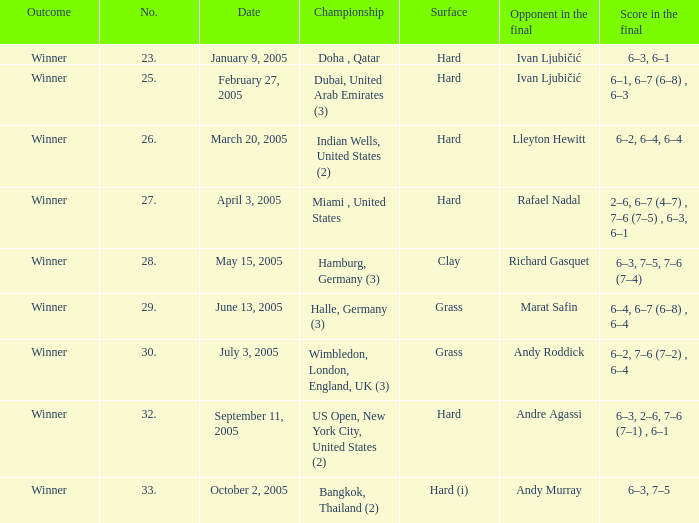In the championship Indian Wells, United States (2), who are the opponents in the final? Lleyton Hewitt. Could you parse the entire table as a dict? {'header': ['Outcome', 'No.', 'Date', 'Championship', 'Surface', 'Opponent in the final', 'Score in the final'], 'rows': [['Winner', '23.', 'January 9, 2005', 'Doha , Qatar', 'Hard', 'Ivan Ljubičić', '6–3, 6–1'], ['Winner', '25.', 'February 27, 2005', 'Dubai, United Arab Emirates (3)', 'Hard', 'Ivan Ljubičić', '6–1, 6–7 (6–8) , 6–3'], ['Winner', '26.', 'March 20, 2005', 'Indian Wells, United States (2)', 'Hard', 'Lleyton Hewitt', '6–2, 6–4, 6–4'], ['Winner', '27.', 'April 3, 2005', 'Miami , United States', 'Hard', 'Rafael Nadal', '2–6, 6–7 (4–7) , 7–6 (7–5) , 6–3, 6–1'], ['Winner', '28.', 'May 15, 2005', 'Hamburg, Germany (3)', 'Clay', 'Richard Gasquet', '6–3, 7–5, 7–6 (7–4)'], ['Winner', '29.', 'June 13, 2005', 'Halle, Germany (3)', 'Grass', 'Marat Safin', '6–4, 6–7 (6–8) , 6–4'], ['Winner', '30.', 'July 3, 2005', 'Wimbledon, London, England, UK (3)', 'Grass', 'Andy Roddick', '6–2, 7–6 (7–2) , 6–4'], ['Winner', '32.', 'September 11, 2005', 'US Open, New York City, United States (2)', 'Hard', 'Andre Agassi', '6–3, 2–6, 7–6 (7–1) , 6–1'], ['Winner', '33.', 'October 2, 2005', 'Bangkok, Thailand (2)', 'Hard (i)', 'Andy Murray', '6–3, 7–5']]} 